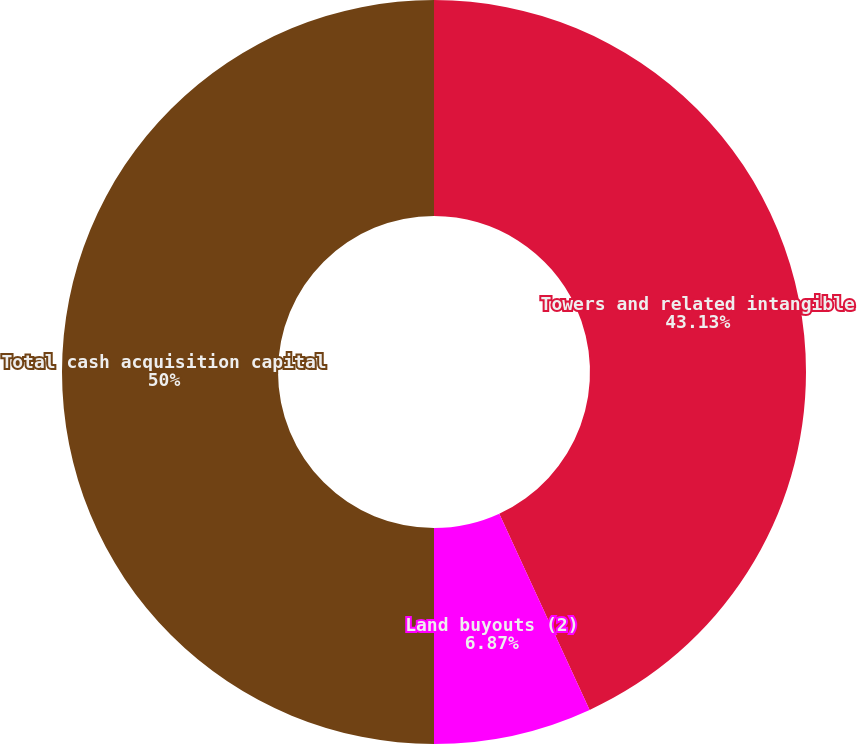<chart> <loc_0><loc_0><loc_500><loc_500><pie_chart><fcel>Towers and related intangible<fcel>Land buyouts (2)<fcel>Total cash acquisition capital<nl><fcel>43.13%<fcel>6.87%<fcel>50.0%<nl></chart> 